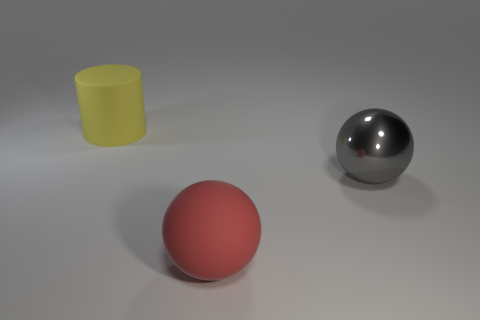Is there a brown sphere of the same size as the metallic object?
Your answer should be very brief. No. There is another metal thing that is the same shape as the red object; what is its color?
Provide a short and direct response. Gray. Are there any large cylinders that are in front of the big thing that is right of the red matte ball?
Make the answer very short. No. There is a object that is in front of the gray shiny sphere; is its shape the same as the large yellow matte thing?
Keep it short and to the point. No. The gray metallic thing has what shape?
Offer a terse response. Sphere. What number of gray things are made of the same material as the large red sphere?
Your response must be concise. 0. There is a rubber ball; does it have the same color as the big rubber thing behind the large gray shiny sphere?
Keep it short and to the point. No. How many cubes are there?
Give a very brief answer. 0. Is there a large sphere that has the same color as the matte cylinder?
Your response must be concise. No. The matte object on the right side of the rubber object behind the big rubber thing that is in front of the large gray shiny ball is what color?
Ensure brevity in your answer.  Red. 